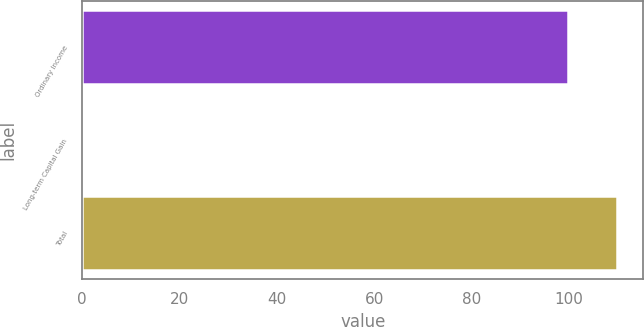Convert chart. <chart><loc_0><loc_0><loc_500><loc_500><bar_chart><fcel>Ordinary Income<fcel>Long-term Capital Gain<fcel>Total<nl><fcel>99.83<fcel>0.17<fcel>109.81<nl></chart> 